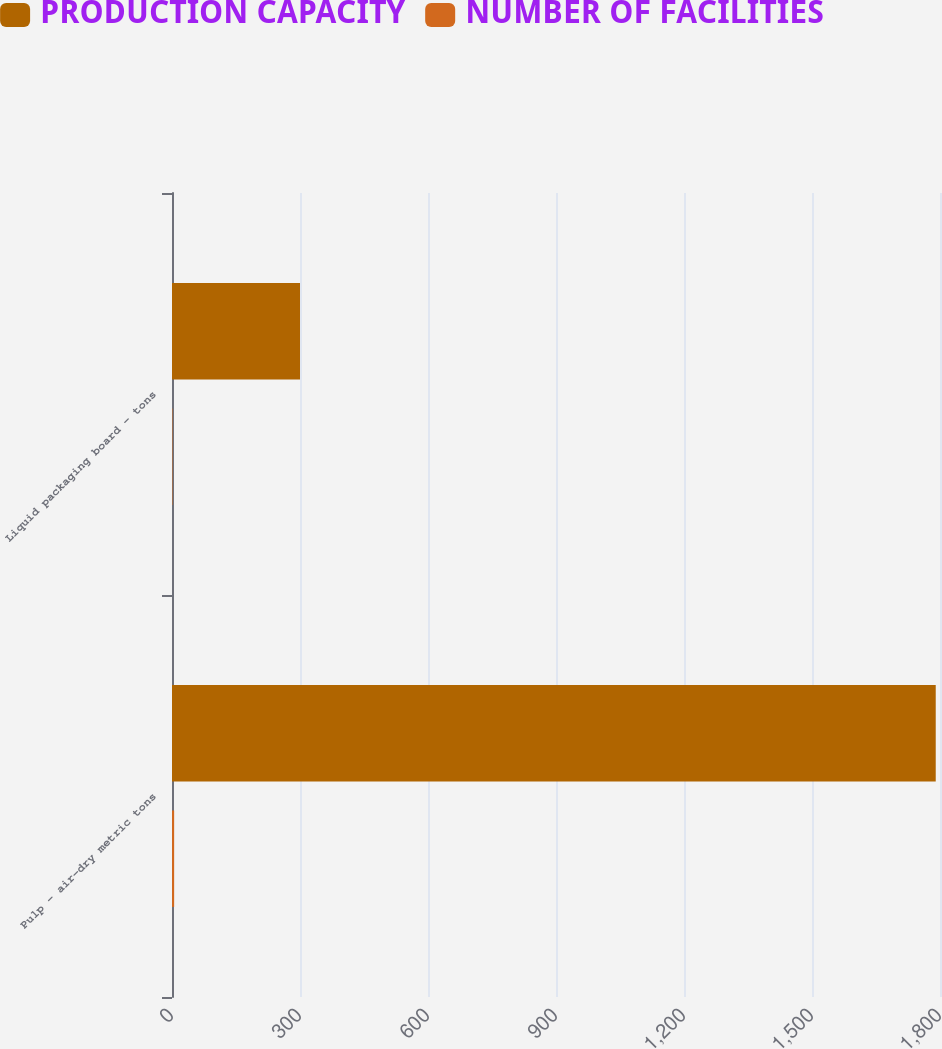Convert chart to OTSL. <chart><loc_0><loc_0><loc_500><loc_500><stacked_bar_chart><ecel><fcel>Pulp - air-dry metric tons<fcel>Liquid packaging board - tons<nl><fcel>PRODUCTION CAPACITY<fcel>1790<fcel>300<nl><fcel>NUMBER OF FACILITIES<fcel>5<fcel>1<nl></chart> 